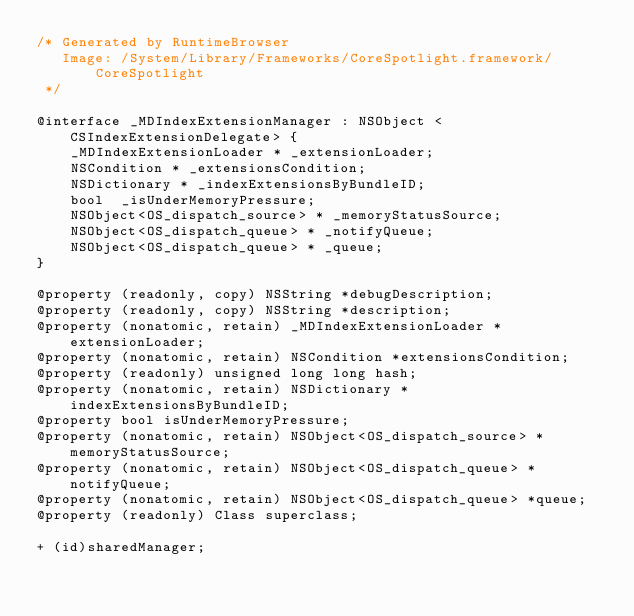Convert code to text. <code><loc_0><loc_0><loc_500><loc_500><_C_>/* Generated by RuntimeBrowser
   Image: /System/Library/Frameworks/CoreSpotlight.framework/CoreSpotlight
 */

@interface _MDIndexExtensionManager : NSObject <CSIndexExtensionDelegate> {
    _MDIndexExtensionLoader * _extensionLoader;
    NSCondition * _extensionsCondition;
    NSDictionary * _indexExtensionsByBundleID;
    bool  _isUnderMemoryPressure;
    NSObject<OS_dispatch_source> * _memoryStatusSource;
    NSObject<OS_dispatch_queue> * _notifyQueue;
    NSObject<OS_dispatch_queue> * _queue;
}

@property (readonly, copy) NSString *debugDescription;
@property (readonly, copy) NSString *description;
@property (nonatomic, retain) _MDIndexExtensionLoader *extensionLoader;
@property (nonatomic, retain) NSCondition *extensionsCondition;
@property (readonly) unsigned long long hash;
@property (nonatomic, retain) NSDictionary *indexExtensionsByBundleID;
@property bool isUnderMemoryPressure;
@property (nonatomic, retain) NSObject<OS_dispatch_source> *memoryStatusSource;
@property (nonatomic, retain) NSObject<OS_dispatch_queue> *notifyQueue;
@property (nonatomic, retain) NSObject<OS_dispatch_queue> *queue;
@property (readonly) Class superclass;

+ (id)sharedManager;
</code> 